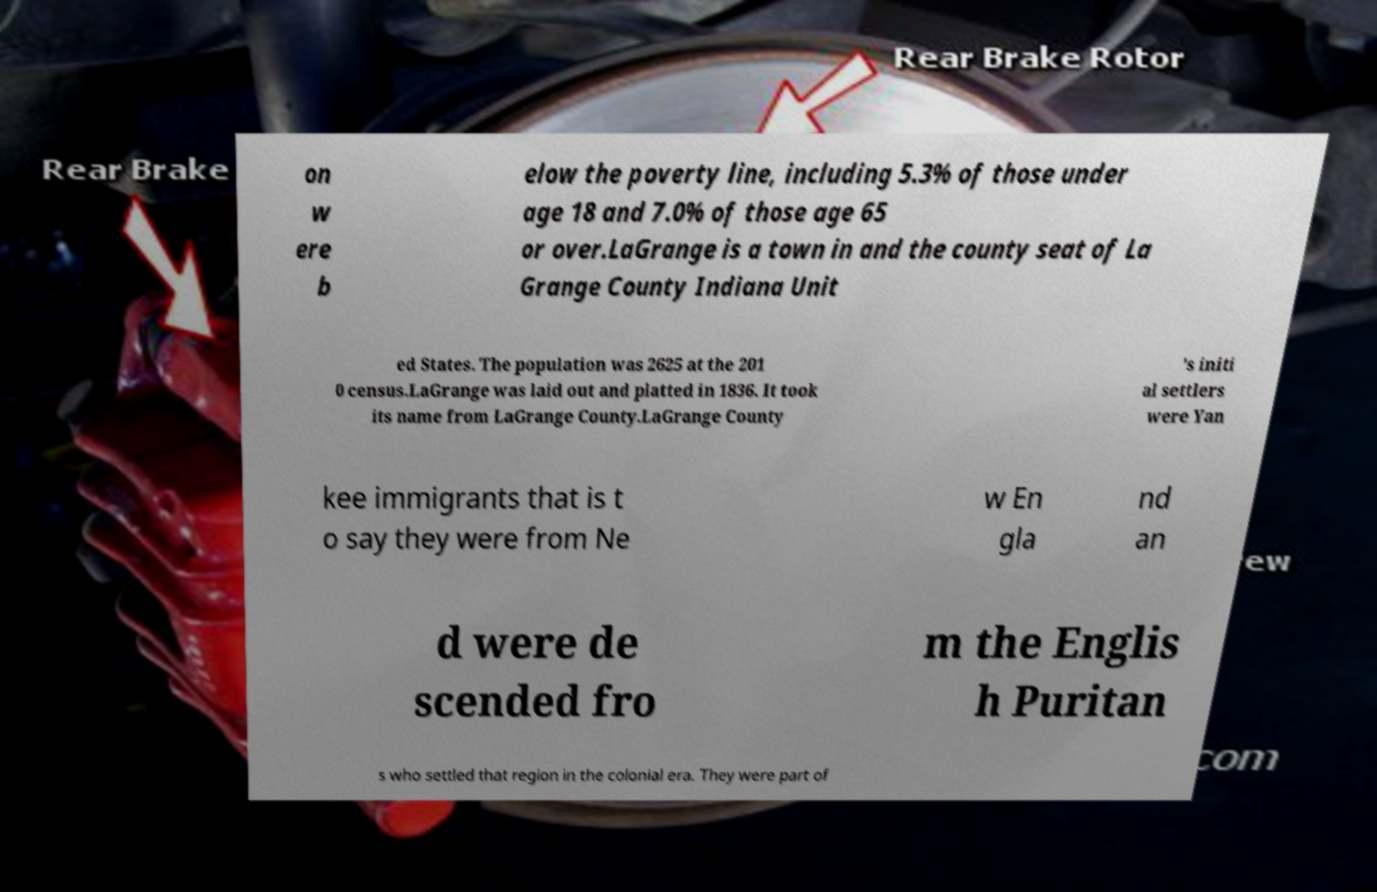Can you read and provide the text displayed in the image?This photo seems to have some interesting text. Can you extract and type it out for me? on w ere b elow the poverty line, including 5.3% of those under age 18 and 7.0% of those age 65 or over.LaGrange is a town in and the county seat of La Grange County Indiana Unit ed States. The population was 2625 at the 201 0 census.LaGrange was laid out and platted in 1836. It took its name from LaGrange County.LaGrange County 's initi al settlers were Yan kee immigrants that is t o say they were from Ne w En gla nd an d were de scended fro m the Englis h Puritan s who settled that region in the colonial era. They were part of 